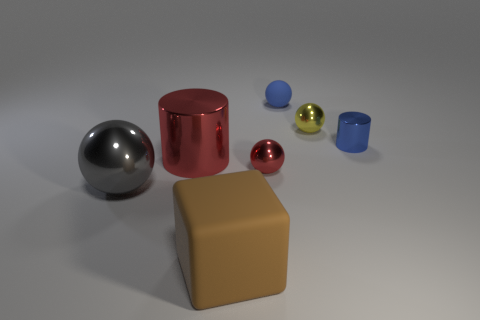How many things are either small red things or things that are in front of the blue shiny cylinder?
Offer a very short reply. 4. The small metal object that is the same color as the large cylinder is what shape?
Give a very brief answer. Sphere. How many blue shiny cylinders are the same size as the brown block?
Provide a short and direct response. 0. How many cyan things are cylinders or matte blocks?
Keep it short and to the point. 0. What shape is the object that is in front of the gray object that is in front of the big red shiny object?
Your response must be concise. Cube. What shape is the blue rubber thing that is the same size as the red sphere?
Make the answer very short. Sphere. Is there a big object that has the same color as the small metal cylinder?
Provide a succinct answer. No. Are there an equal number of big shiny cylinders right of the matte sphere and metal spheres in front of the red metallic ball?
Provide a short and direct response. No. There is a small matte object; is its shape the same as the small object that is on the left side of the blue sphere?
Offer a terse response. Yes. How many other objects are there of the same material as the tiny yellow thing?
Provide a succinct answer. 4. 